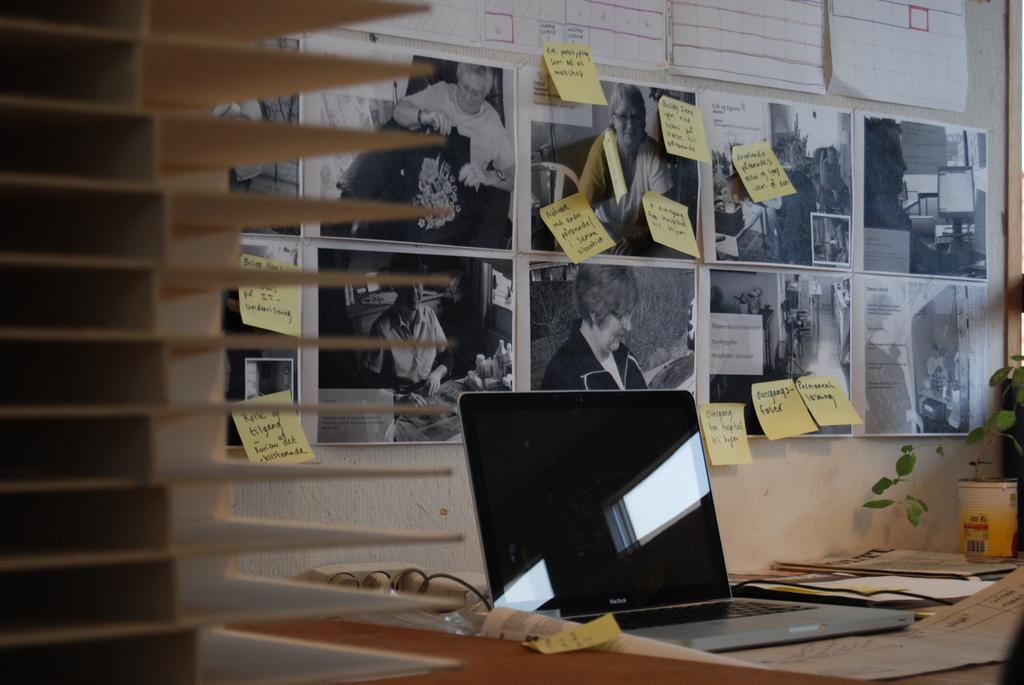What is hanging on the wall in the image? There is a picture, notes, and a poster on the wall in the image. What can be seen on the table in the image? There is a laptop and a paper on the table in the image. Is there any greenery visible in the image? Yes, there is a plant visible in the image. Can you see a toad sitting on the laptop in the image? No, there is no toad present in the image. Is there a coil of wire visible on the table in the image? No, there is no coil of wire visible in the image. 